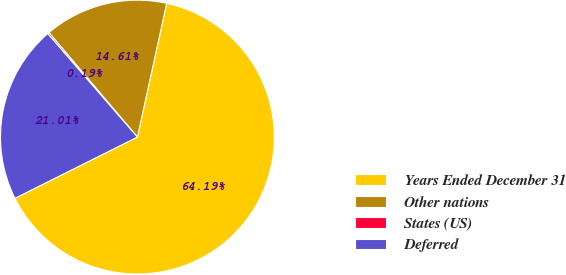Convert chart. <chart><loc_0><loc_0><loc_500><loc_500><pie_chart><fcel>Years Ended December 31<fcel>Other nations<fcel>States (US)<fcel>Deferred<nl><fcel>64.19%<fcel>14.61%<fcel>0.19%<fcel>21.01%<nl></chart> 